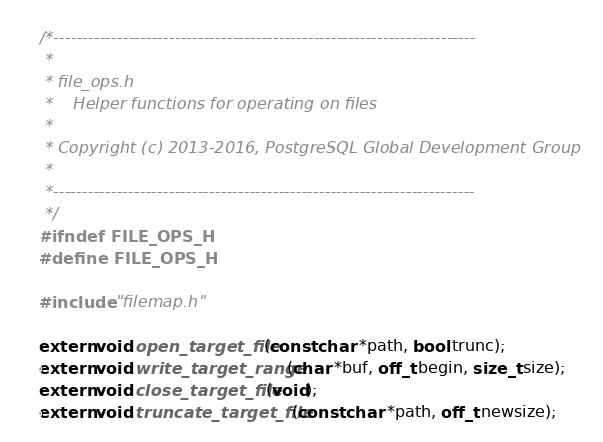Convert code to text. <code><loc_0><loc_0><loc_500><loc_500><_C_>/*-------------------------------------------------------------------------
 *
 * file_ops.h
 *	  Helper functions for operating on files
 *
 * Copyright (c) 2013-2016, PostgreSQL Global Development Group
 *
 *-------------------------------------------------------------------------
 */
#ifndef FILE_OPS_H
#define FILE_OPS_H

#include "filemap.h"

extern void open_target_file(const char *path, bool trunc);
extern void write_target_range(char *buf, off_t begin, size_t size);
extern void close_target_file(void);
extern void truncate_target_file(const char *path, off_t newsize);</code> 